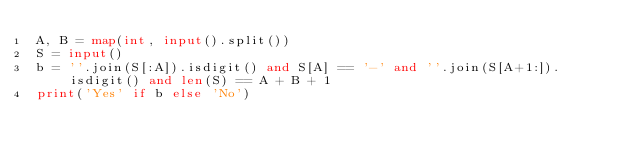<code> <loc_0><loc_0><loc_500><loc_500><_Python_>A, B = map(int, input().split())
S = input()
b = ''.join(S[:A]).isdigit() and S[A] == '-' and ''.join(S[A+1:]).isdigit() and len(S) == A + B + 1
print('Yes' if b else 'No')</code> 